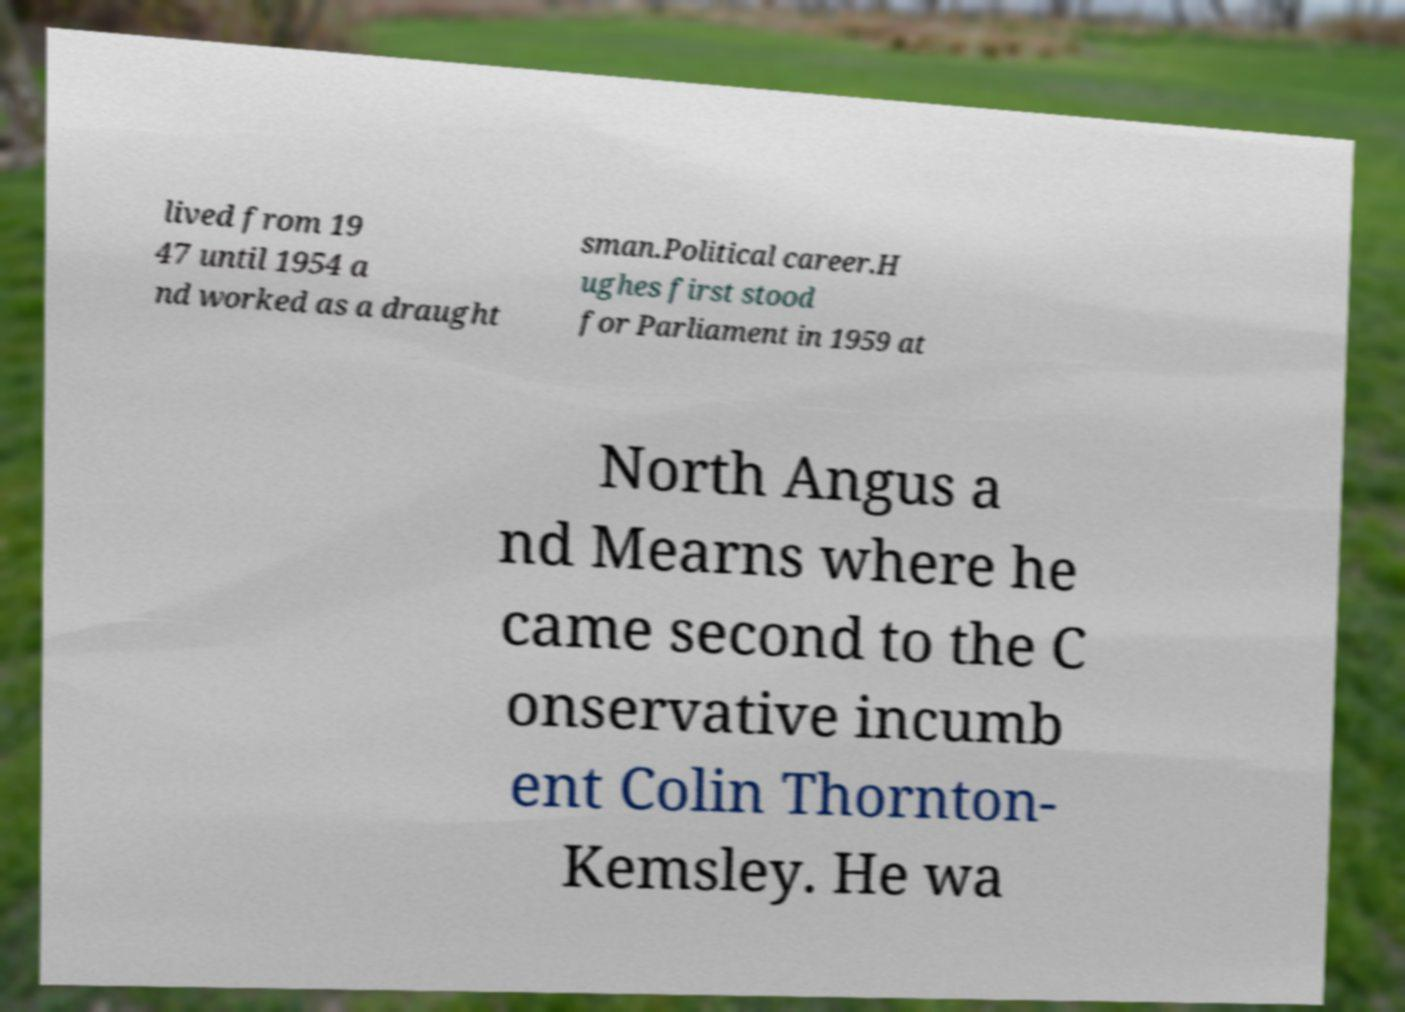Could you assist in decoding the text presented in this image and type it out clearly? lived from 19 47 until 1954 a nd worked as a draught sman.Political career.H ughes first stood for Parliament in 1959 at North Angus a nd Mearns where he came second to the C onservative incumb ent Colin Thornton- Kemsley. He wa 